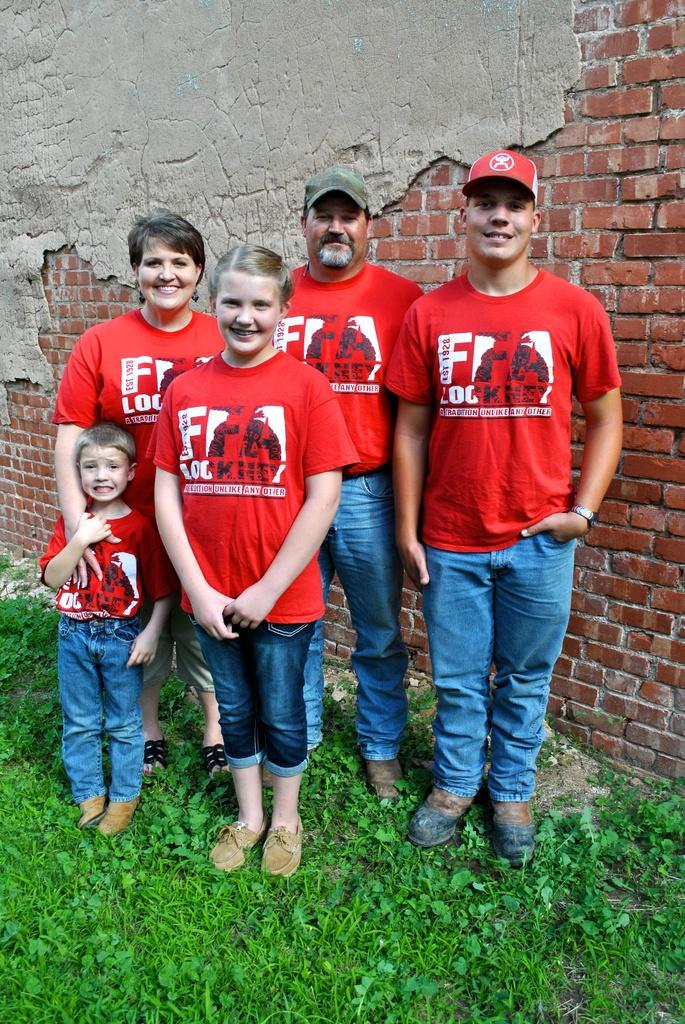How many people are in the image? There are five persons in the image. What are the people wearing on their upper bodies? Each person is wearing a red dress. What type of pants are the people wearing? Each person is wearing jeans pants. What is the ground like where the people are standing? The persons are standing on a greenery ground. What is visible behind the persons? There is a wall behind the persons. What type of loaf can be seen on the wall behind the persons? There is no loaf present on the wall behind the persons in the image. What color is the can that is being held by one of the persons? There is no can visible in the image; the persons are not holding any objects. 